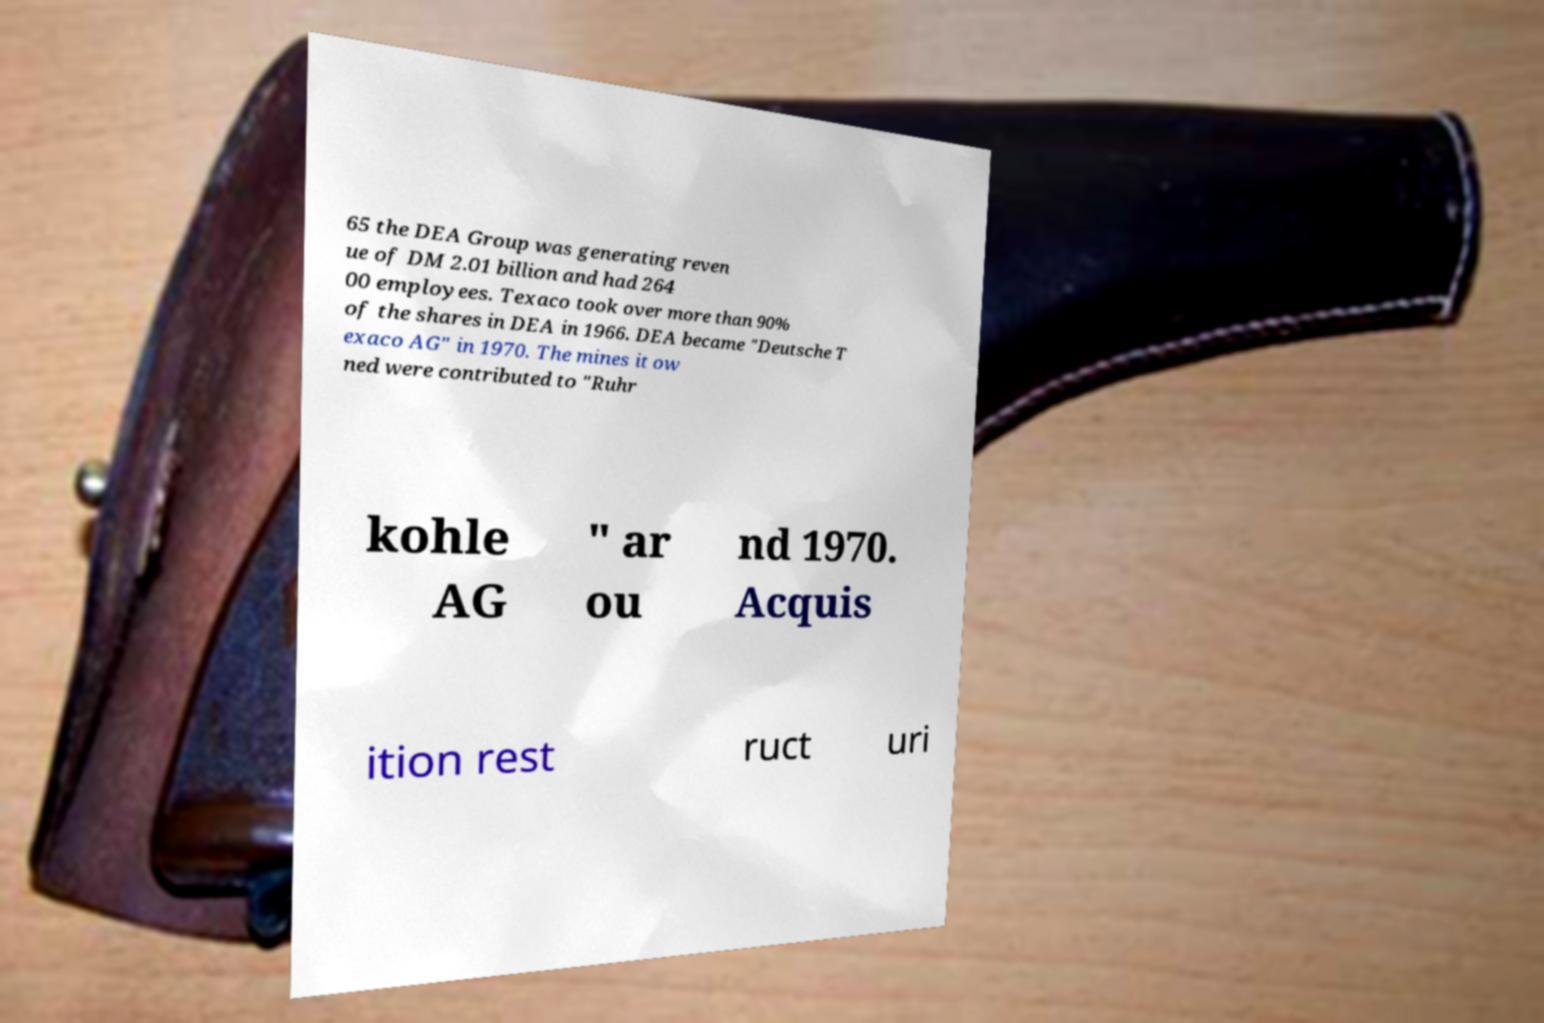Please identify and transcribe the text found in this image. 65 the DEA Group was generating reven ue of DM 2.01 billion and had 264 00 employees. Texaco took over more than 90% of the shares in DEA in 1966. DEA became "Deutsche T exaco AG" in 1970. The mines it ow ned were contributed to "Ruhr kohle AG " ar ou nd 1970. Acquis ition rest ruct uri 